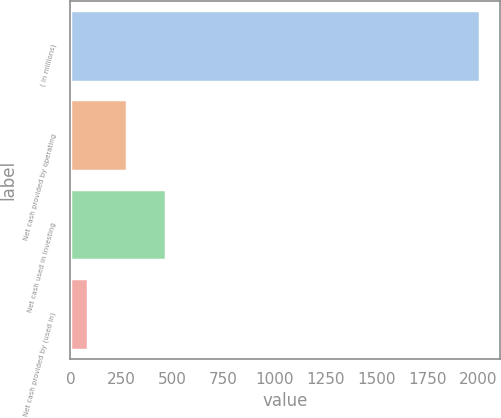Convert chart. <chart><loc_0><loc_0><loc_500><loc_500><bar_chart><fcel>( in millions)<fcel>Net cash provided by operating<fcel>Net cash used in investing<fcel>Net cash provided by (used in)<nl><fcel>2007<fcel>276.84<fcel>469.08<fcel>84.6<nl></chart> 